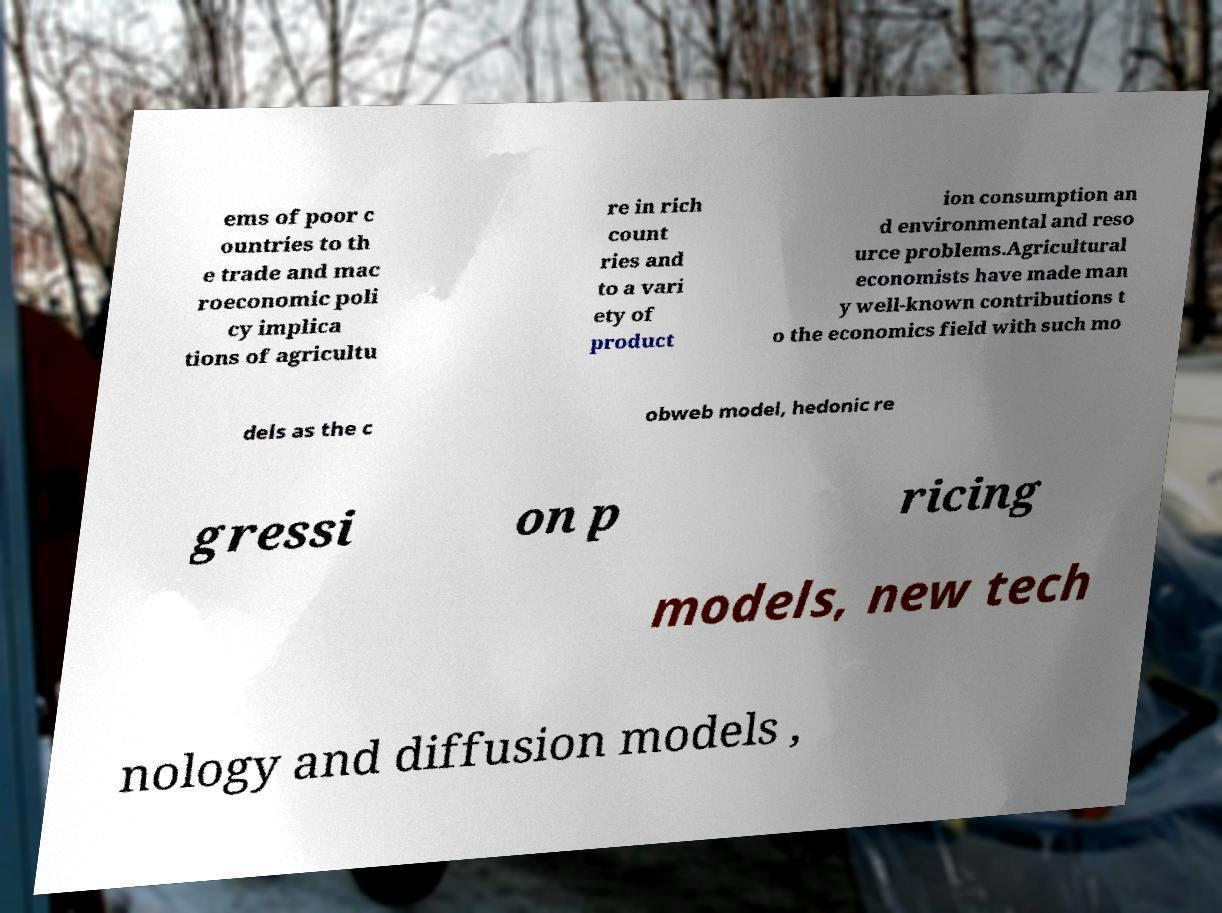Please identify and transcribe the text found in this image. ems of poor c ountries to th e trade and mac roeconomic poli cy implica tions of agricultu re in rich count ries and to a vari ety of product ion consumption an d environmental and reso urce problems.Agricultural economists have made man y well-known contributions t o the economics field with such mo dels as the c obweb model, hedonic re gressi on p ricing models, new tech nology and diffusion models , 